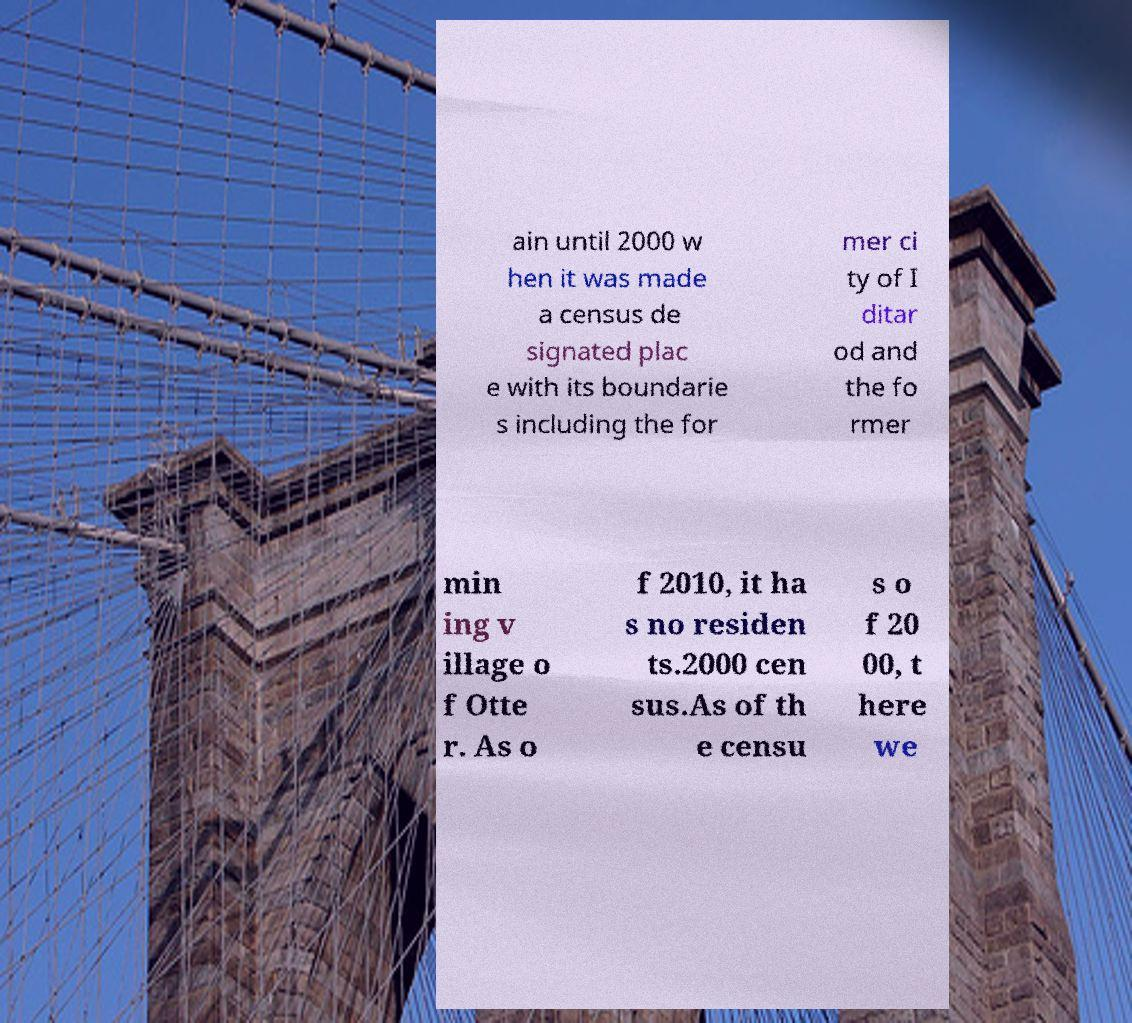Can you read and provide the text displayed in the image?This photo seems to have some interesting text. Can you extract and type it out for me? ain until 2000 w hen it was made a census de signated plac e with its boundarie s including the for mer ci ty of I ditar od and the fo rmer min ing v illage o f Otte r. As o f 2010, it ha s no residen ts.2000 cen sus.As of th e censu s o f 20 00, t here we 